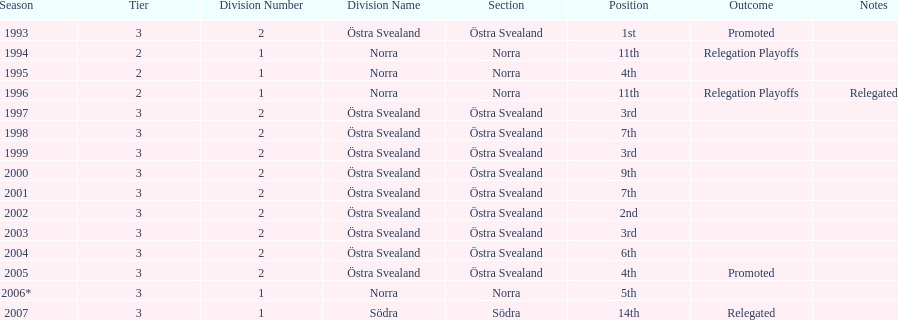What is the only year with the 1st position? 1993. Can you give me this table as a dict? {'header': ['Season', 'Tier', 'Division Number', 'Division Name', 'Section', 'Position', 'Outcome', 'Notes'], 'rows': [['1993', '3', '2', 'Östra Svealand', 'Östra Svealand', '1st', 'Promoted', ''], ['1994', '2', '1', 'Norra', 'Norra', '11th', 'Relegation Playoffs', ''], ['1995', '2', '1', 'Norra', 'Norra', '4th', '', ''], ['1996', '2', '1', 'Norra', 'Norra', '11th', 'Relegation Playoffs', 'Relegated'], ['1997', '3', '2', 'Östra Svealand', 'Östra Svealand', '3rd', '', ''], ['1998', '3', '2', 'Östra Svealand', 'Östra Svealand', '7th', '', ''], ['1999', '3', '2', 'Östra Svealand', 'Östra Svealand', '3rd', '', ''], ['2000', '3', '2', 'Östra Svealand', 'Östra Svealand', '9th', '', ''], ['2001', '3', '2', 'Östra Svealand', 'Östra Svealand', '7th', '', ''], ['2002', '3', '2', 'Östra Svealand', 'Östra Svealand', '2nd', '', ''], ['2003', '3', '2', 'Östra Svealand', 'Östra Svealand', '3rd', '', ''], ['2004', '3', '2', 'Östra Svealand', 'Östra Svealand', '6th', '', ''], ['2005', '3', '2', 'Östra Svealand', 'Östra Svealand', '4th', 'Promoted', ''], ['2006*', '3', '1', 'Norra', 'Norra', '5th', '', ''], ['2007', '3', '1', 'Södra', 'Södra', '14th', 'Relegated', '']]} 